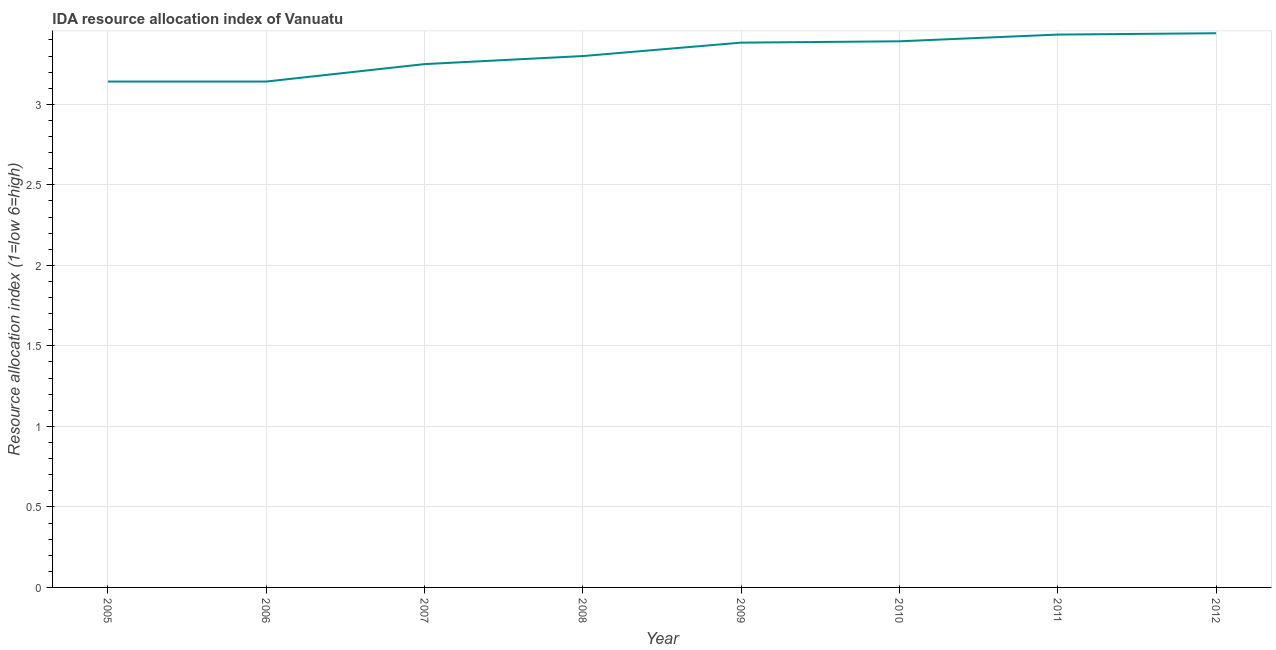What is the ida resource allocation index in 2010?
Ensure brevity in your answer.  3.39. Across all years, what is the maximum ida resource allocation index?
Ensure brevity in your answer.  3.44. Across all years, what is the minimum ida resource allocation index?
Give a very brief answer. 3.14. In which year was the ida resource allocation index maximum?
Give a very brief answer. 2012. What is the sum of the ida resource allocation index?
Provide a short and direct response. 26.48. What is the average ida resource allocation index per year?
Your answer should be very brief. 3.31. What is the median ida resource allocation index?
Offer a very short reply. 3.34. What is the ratio of the ida resource allocation index in 2005 to that in 2010?
Ensure brevity in your answer.  0.93. Is the ida resource allocation index in 2006 less than that in 2009?
Offer a very short reply. Yes. What is the difference between the highest and the second highest ida resource allocation index?
Your response must be concise. 0.01. Is the sum of the ida resource allocation index in 2010 and 2012 greater than the maximum ida resource allocation index across all years?
Your response must be concise. Yes. What is the difference between the highest and the lowest ida resource allocation index?
Give a very brief answer. 0.3. In how many years, is the ida resource allocation index greater than the average ida resource allocation index taken over all years?
Provide a short and direct response. 4. Does the ida resource allocation index monotonically increase over the years?
Ensure brevity in your answer.  No. How many years are there in the graph?
Offer a very short reply. 8. What is the difference between two consecutive major ticks on the Y-axis?
Offer a terse response. 0.5. Are the values on the major ticks of Y-axis written in scientific E-notation?
Keep it short and to the point. No. Does the graph contain any zero values?
Make the answer very short. No. What is the title of the graph?
Provide a short and direct response. IDA resource allocation index of Vanuatu. What is the label or title of the X-axis?
Make the answer very short. Year. What is the label or title of the Y-axis?
Offer a very short reply. Resource allocation index (1=low 6=high). What is the Resource allocation index (1=low 6=high) in 2005?
Provide a succinct answer. 3.14. What is the Resource allocation index (1=low 6=high) in 2006?
Your answer should be very brief. 3.14. What is the Resource allocation index (1=low 6=high) in 2007?
Ensure brevity in your answer.  3.25. What is the Resource allocation index (1=low 6=high) in 2008?
Your answer should be very brief. 3.3. What is the Resource allocation index (1=low 6=high) of 2009?
Your response must be concise. 3.38. What is the Resource allocation index (1=low 6=high) of 2010?
Offer a terse response. 3.39. What is the Resource allocation index (1=low 6=high) in 2011?
Make the answer very short. 3.43. What is the Resource allocation index (1=low 6=high) of 2012?
Keep it short and to the point. 3.44. What is the difference between the Resource allocation index (1=low 6=high) in 2005 and 2006?
Give a very brief answer. 0. What is the difference between the Resource allocation index (1=low 6=high) in 2005 and 2007?
Your answer should be very brief. -0.11. What is the difference between the Resource allocation index (1=low 6=high) in 2005 and 2008?
Keep it short and to the point. -0.16. What is the difference between the Resource allocation index (1=low 6=high) in 2005 and 2009?
Give a very brief answer. -0.24. What is the difference between the Resource allocation index (1=low 6=high) in 2005 and 2010?
Offer a very short reply. -0.25. What is the difference between the Resource allocation index (1=low 6=high) in 2005 and 2011?
Make the answer very short. -0.29. What is the difference between the Resource allocation index (1=low 6=high) in 2005 and 2012?
Offer a very short reply. -0.3. What is the difference between the Resource allocation index (1=low 6=high) in 2006 and 2007?
Offer a terse response. -0.11. What is the difference between the Resource allocation index (1=low 6=high) in 2006 and 2008?
Offer a very short reply. -0.16. What is the difference between the Resource allocation index (1=low 6=high) in 2006 and 2009?
Give a very brief answer. -0.24. What is the difference between the Resource allocation index (1=low 6=high) in 2006 and 2010?
Keep it short and to the point. -0.25. What is the difference between the Resource allocation index (1=low 6=high) in 2006 and 2011?
Your response must be concise. -0.29. What is the difference between the Resource allocation index (1=low 6=high) in 2007 and 2008?
Offer a very short reply. -0.05. What is the difference between the Resource allocation index (1=low 6=high) in 2007 and 2009?
Your answer should be compact. -0.13. What is the difference between the Resource allocation index (1=low 6=high) in 2007 and 2010?
Provide a short and direct response. -0.14. What is the difference between the Resource allocation index (1=low 6=high) in 2007 and 2011?
Your answer should be compact. -0.18. What is the difference between the Resource allocation index (1=low 6=high) in 2007 and 2012?
Make the answer very short. -0.19. What is the difference between the Resource allocation index (1=low 6=high) in 2008 and 2009?
Ensure brevity in your answer.  -0.08. What is the difference between the Resource allocation index (1=low 6=high) in 2008 and 2010?
Provide a succinct answer. -0.09. What is the difference between the Resource allocation index (1=low 6=high) in 2008 and 2011?
Offer a terse response. -0.13. What is the difference between the Resource allocation index (1=low 6=high) in 2008 and 2012?
Ensure brevity in your answer.  -0.14. What is the difference between the Resource allocation index (1=low 6=high) in 2009 and 2010?
Your answer should be very brief. -0.01. What is the difference between the Resource allocation index (1=low 6=high) in 2009 and 2012?
Provide a short and direct response. -0.06. What is the difference between the Resource allocation index (1=low 6=high) in 2010 and 2011?
Make the answer very short. -0.04. What is the difference between the Resource allocation index (1=low 6=high) in 2010 and 2012?
Offer a very short reply. -0.05. What is the difference between the Resource allocation index (1=low 6=high) in 2011 and 2012?
Give a very brief answer. -0.01. What is the ratio of the Resource allocation index (1=low 6=high) in 2005 to that in 2009?
Offer a very short reply. 0.93. What is the ratio of the Resource allocation index (1=low 6=high) in 2005 to that in 2010?
Ensure brevity in your answer.  0.93. What is the ratio of the Resource allocation index (1=low 6=high) in 2005 to that in 2011?
Offer a terse response. 0.92. What is the ratio of the Resource allocation index (1=low 6=high) in 2005 to that in 2012?
Your response must be concise. 0.91. What is the ratio of the Resource allocation index (1=low 6=high) in 2006 to that in 2008?
Your answer should be compact. 0.95. What is the ratio of the Resource allocation index (1=low 6=high) in 2006 to that in 2009?
Your answer should be very brief. 0.93. What is the ratio of the Resource allocation index (1=low 6=high) in 2006 to that in 2010?
Your answer should be very brief. 0.93. What is the ratio of the Resource allocation index (1=low 6=high) in 2006 to that in 2011?
Your answer should be very brief. 0.92. What is the ratio of the Resource allocation index (1=low 6=high) in 2006 to that in 2012?
Your answer should be very brief. 0.91. What is the ratio of the Resource allocation index (1=low 6=high) in 2007 to that in 2010?
Make the answer very short. 0.96. What is the ratio of the Resource allocation index (1=low 6=high) in 2007 to that in 2011?
Offer a very short reply. 0.95. What is the ratio of the Resource allocation index (1=low 6=high) in 2007 to that in 2012?
Your answer should be compact. 0.94. What is the ratio of the Resource allocation index (1=low 6=high) in 2008 to that in 2009?
Provide a succinct answer. 0.97. What is the ratio of the Resource allocation index (1=low 6=high) in 2008 to that in 2010?
Make the answer very short. 0.97. What is the ratio of the Resource allocation index (1=low 6=high) in 2008 to that in 2011?
Your response must be concise. 0.96. What is the ratio of the Resource allocation index (1=low 6=high) in 2009 to that in 2010?
Provide a short and direct response. 1. What is the ratio of the Resource allocation index (1=low 6=high) in 2010 to that in 2012?
Ensure brevity in your answer.  0.98. What is the ratio of the Resource allocation index (1=low 6=high) in 2011 to that in 2012?
Offer a very short reply. 1. 